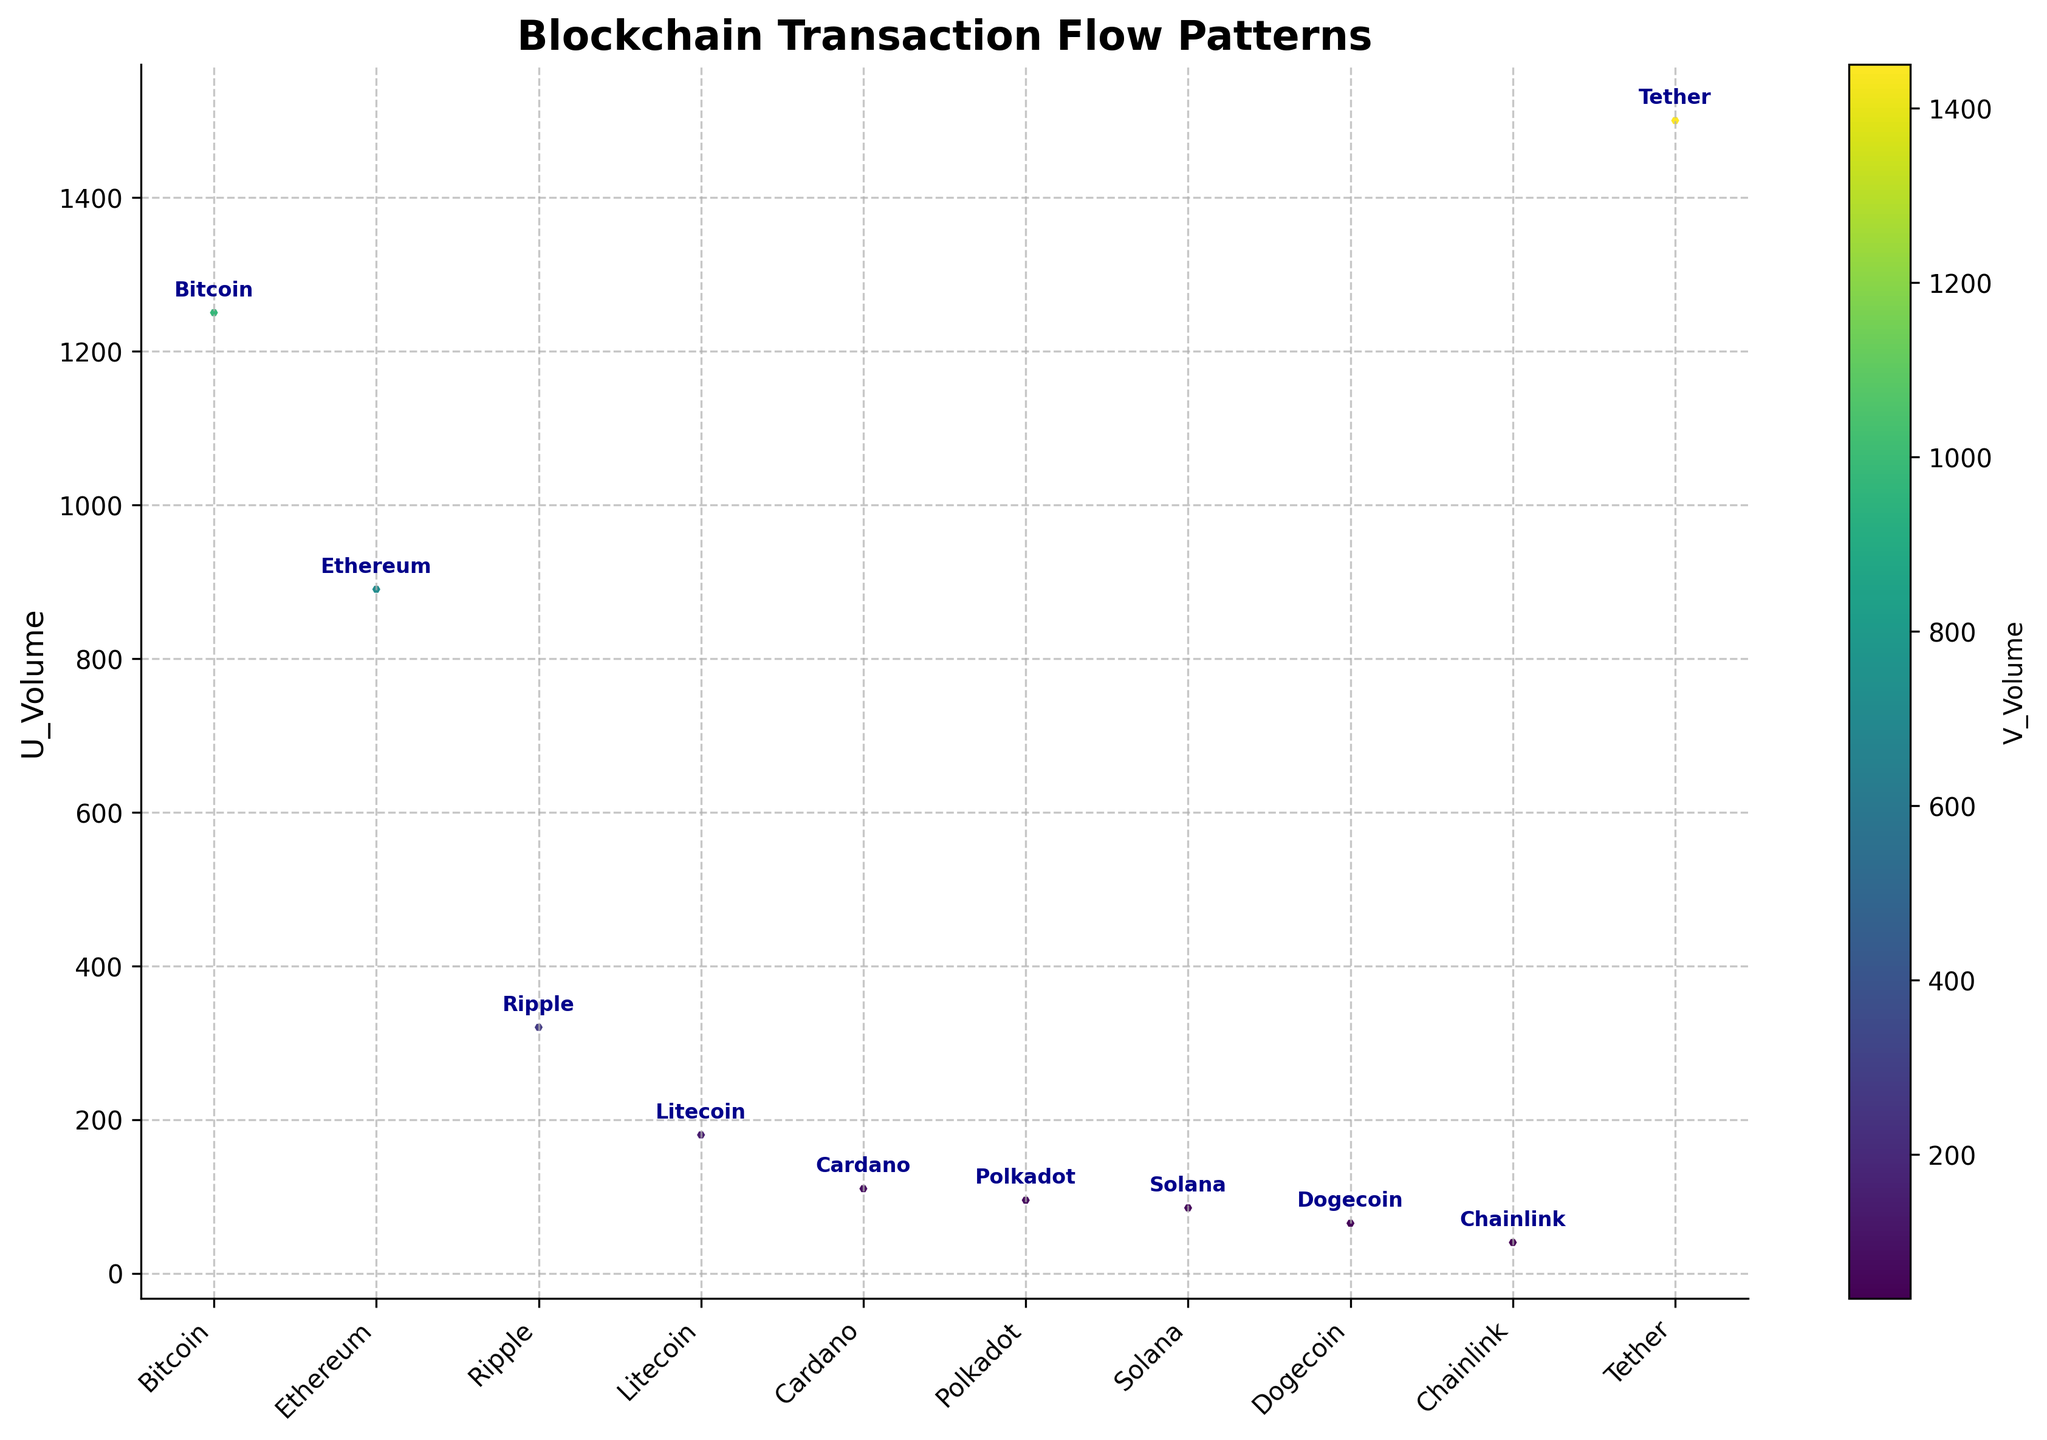what is the title of the figure? The title of the figure is easily identifiable as it is displayed at the top of the plot. It reads "Blockchain Transaction Flow Patterns," indicating the focus of the visualization.
Answer: Blockchain Transaction Flow Patterns How many cryptocurrencies are represented in the figure? Each data point on the x-axis is labeled with the name of a cryptocurrency. By counting these labels, you can determine the number of cryptocurrencies represented.
Answer: 10 Which cryptocurrency shows the highest U_Volume? The y-values represent U_Volume, and the highest point on the y-axis indicates the cryptocurrency with the highest U_Volume. Bitcoin has the highest point on the y-axis.
Answer: Bitcoin What cryptocurrency has a large V_Volume but a short vector? V_Volume is reflected in the color bar, and the short vectors can be identified by observing the arrows' lengths. Examining the plot, Tether has both a large V_Volume and a short vector.
Answer: Tether Which vector points most significantly in the negative x-direction? The direction of the vectors can be distinguished by their orientation. The vector pointing the most negatively in the x-direction is facing the farthest left. Bitcoin's vector has a significant negative x-direction with a direction of -0.8.
Answer: Bitcoin What's the total sum of U_Volume for all cryptocurrencies? To calculate this, sum all the U_Volume values provided in the data. The data gives us 1250 + 890 + 320 + 180 + 110 + 95 + 85 + 65 + 40 + 1500 = 4535.
Answer: 4535 Which cryptocurrencies have vectors pointing both positively in the x and y directions? By examining the direction of the arrows, those that point positively in both the x and y directions are identified. Ripple and Cardano have vectors with both positive x and y directions.
Answer: Ripple and Cardano Which cryptocurrency has its vector pointing most significantly in the positive y-direction and what is its direction vector? The direction vector indicates the y-component; the most positive y-direction indicates the highest value of Direction_Y. Ripple has the most positive y-direction with a value of 0.9 for Direction_Y.
Answer: Ripple, 0.3, 0.9 